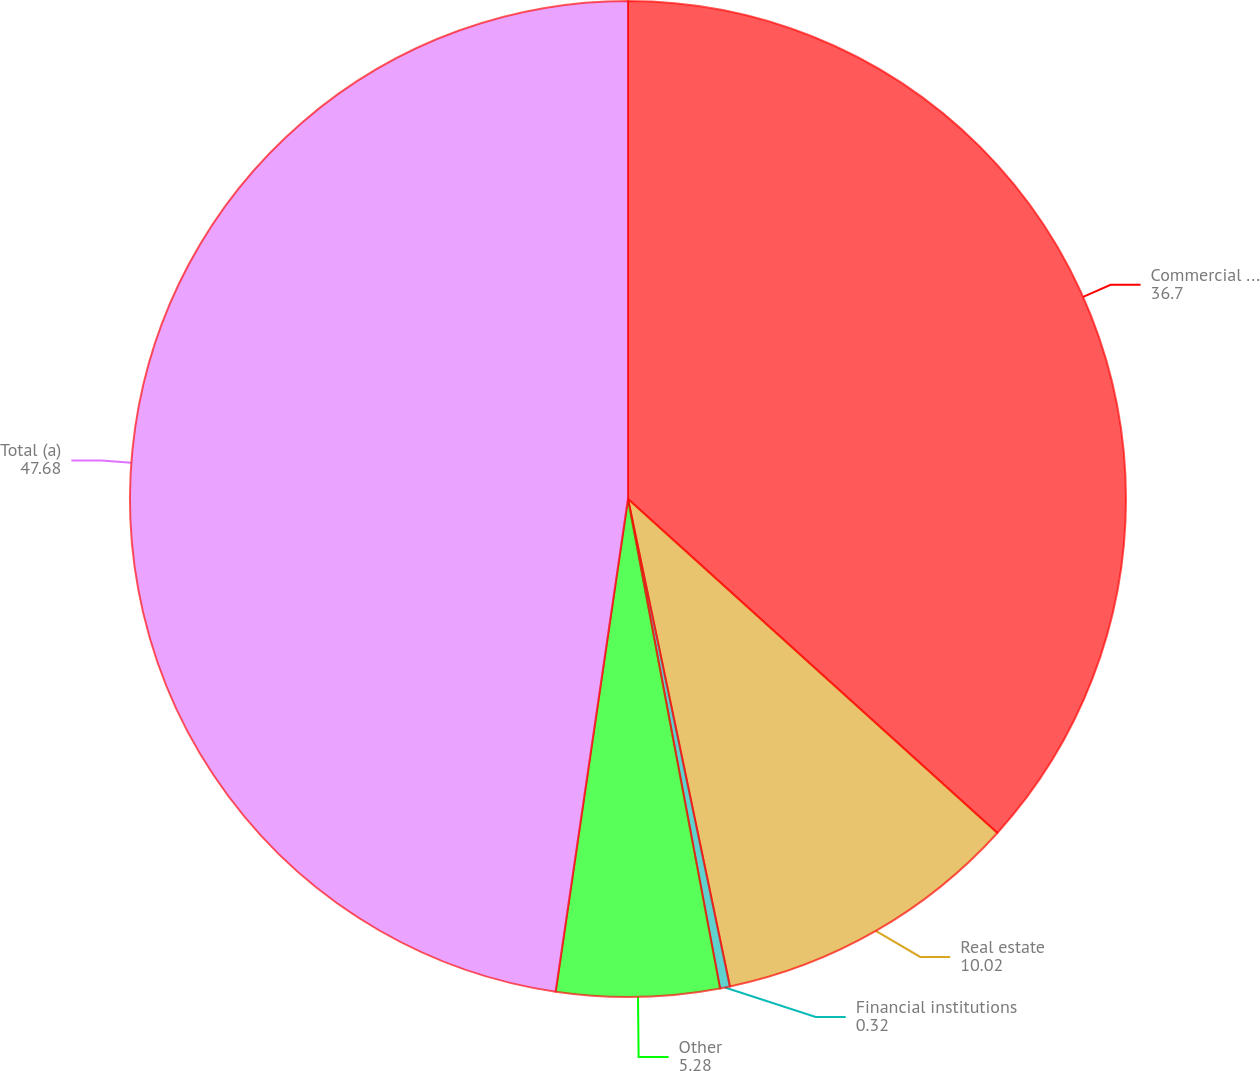Convert chart. <chart><loc_0><loc_0><loc_500><loc_500><pie_chart><fcel>Commercial and industrial<fcel>Real estate<fcel>Financial institutions<fcel>Other<fcel>Total (a)<nl><fcel>36.7%<fcel>10.02%<fcel>0.32%<fcel>5.28%<fcel>47.68%<nl></chart> 